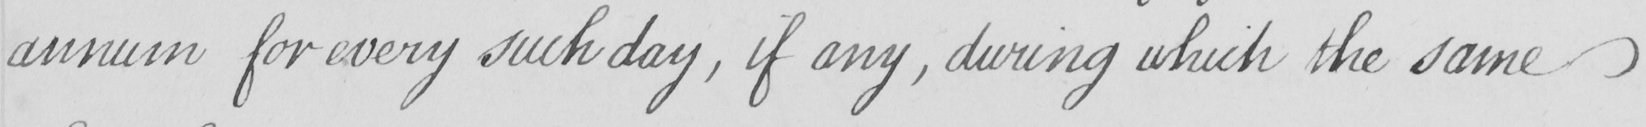Can you tell me what this handwritten text says? annum for every such day , if any , during which the same 